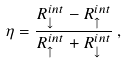<formula> <loc_0><loc_0><loc_500><loc_500>\eta = \frac { R _ { \downarrow } ^ { i n t } - R _ { \uparrow } ^ { i n t } } { R _ { \uparrow } ^ { i n t } + R _ { \downarrow } ^ { i n t } } \, ,</formula> 